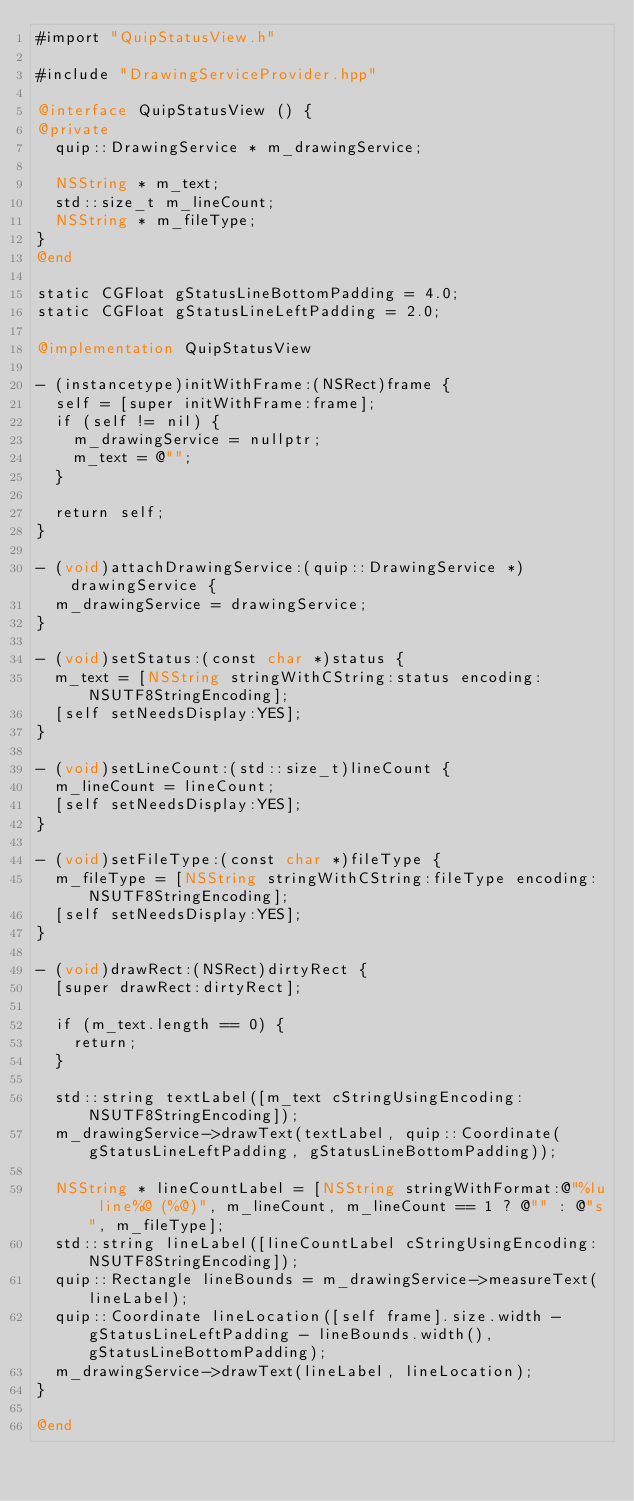<code> <loc_0><loc_0><loc_500><loc_500><_ObjectiveC_>#import "QuipStatusView.h"

#include "DrawingServiceProvider.hpp"

@interface QuipStatusView () {
@private
  quip::DrawingService * m_drawingService;
  
  NSString * m_text;
  std::size_t m_lineCount;
  NSString * m_fileType;
}
@end

static CGFloat gStatusLineBottomPadding = 4.0;
static CGFloat gStatusLineLeftPadding = 2.0;

@implementation QuipStatusView

- (instancetype)initWithFrame:(NSRect)frame {
  self = [super initWithFrame:frame];
  if (self != nil) {
    m_drawingService = nullptr;
    m_text = @"";
  }
  
  return self;
}

- (void)attachDrawingService:(quip::DrawingService *)drawingService {
  m_drawingService = drawingService;
}

- (void)setStatus:(const char *)status {
  m_text = [NSString stringWithCString:status encoding:NSUTF8StringEncoding];
  [self setNeedsDisplay:YES];
}

- (void)setLineCount:(std::size_t)lineCount {
  m_lineCount = lineCount;
  [self setNeedsDisplay:YES];
}

- (void)setFileType:(const char *)fileType {
  m_fileType = [NSString stringWithCString:fileType encoding:NSUTF8StringEncoding];
  [self setNeedsDisplay:YES];
}

- (void)drawRect:(NSRect)dirtyRect {
  [super drawRect:dirtyRect];
  
  if (m_text.length == 0) {
    return;
  }
  
  std::string textLabel([m_text cStringUsingEncoding:NSUTF8StringEncoding]);
  m_drawingService->drawText(textLabel, quip::Coordinate(gStatusLineLeftPadding, gStatusLineBottomPadding));
  
  NSString * lineCountLabel = [NSString stringWithFormat:@"%lu line%@ (%@)", m_lineCount, m_lineCount == 1 ? @"" : @"s", m_fileType];
  std::string lineLabel([lineCountLabel cStringUsingEncoding:NSUTF8StringEncoding]);
  quip::Rectangle lineBounds = m_drawingService->measureText(lineLabel);
  quip::Coordinate lineLocation([self frame].size.width - gStatusLineLeftPadding - lineBounds.width(), gStatusLineBottomPadding);
  m_drawingService->drawText(lineLabel, lineLocation);
}

@end
</code> 